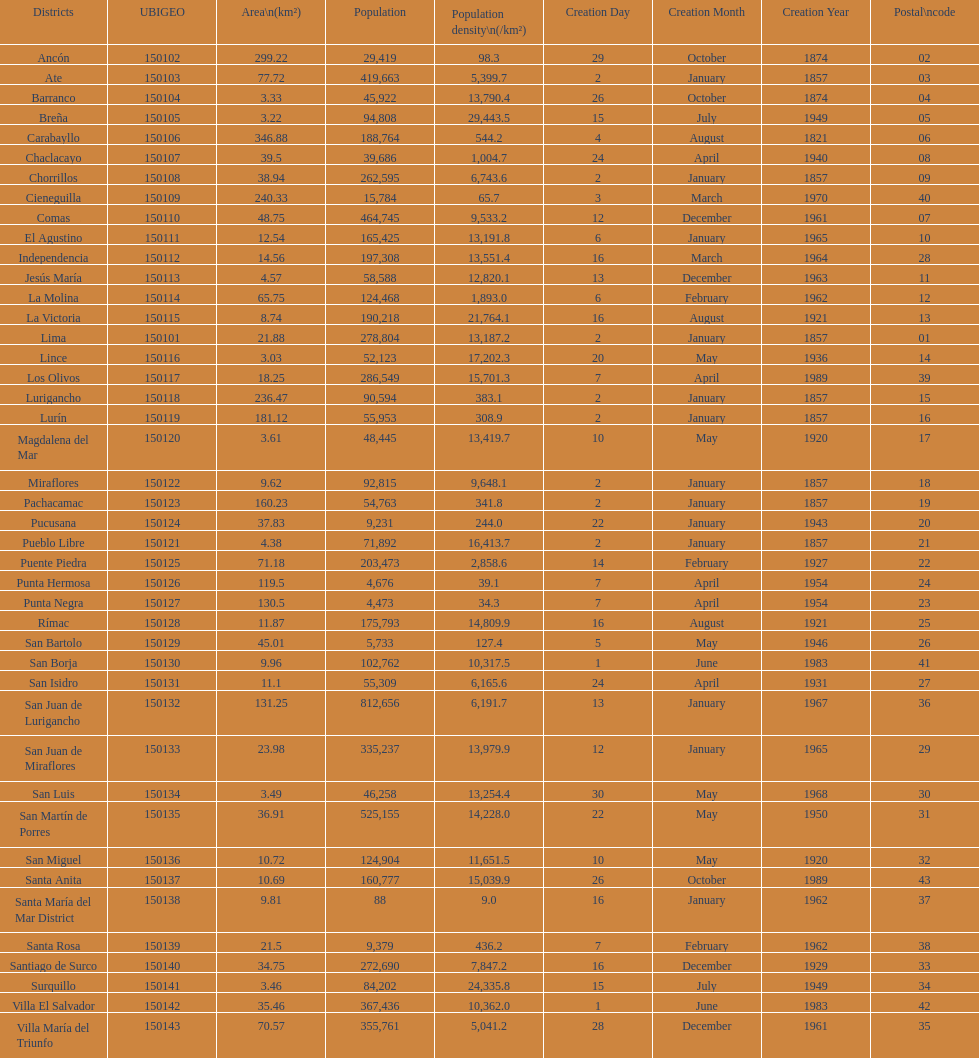How many districts have a population density of at lest 1000.0? 31. 